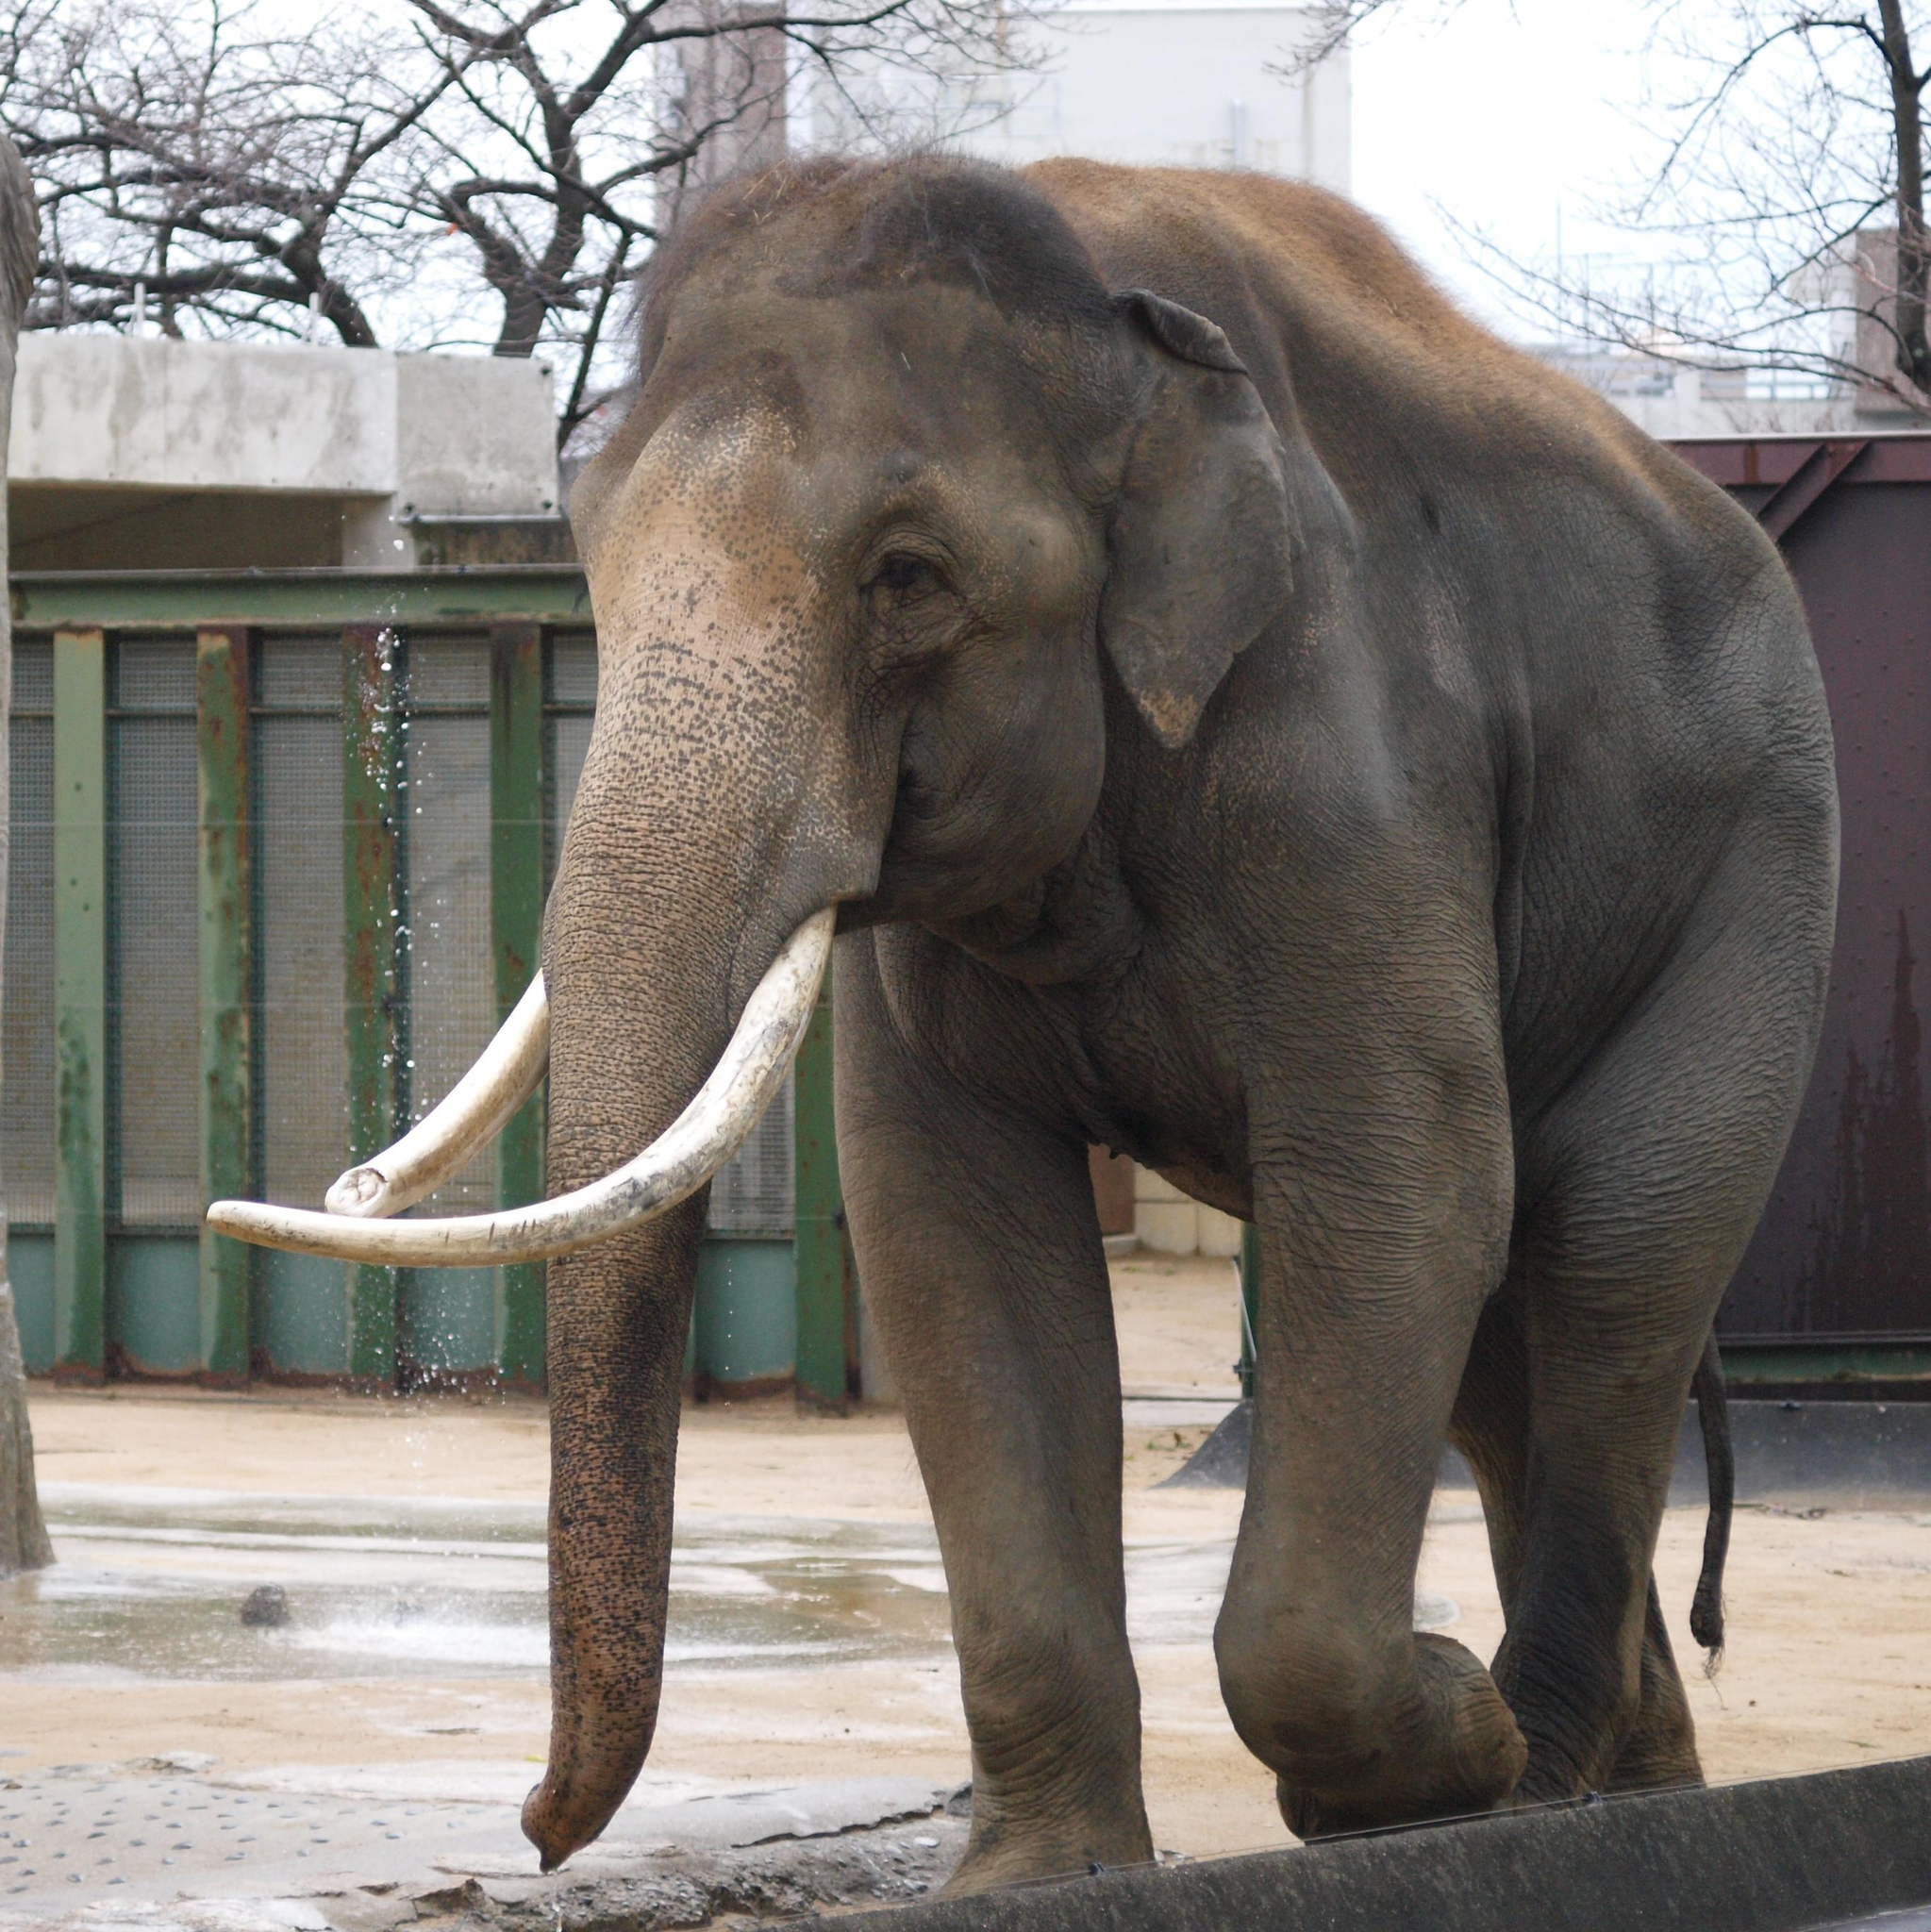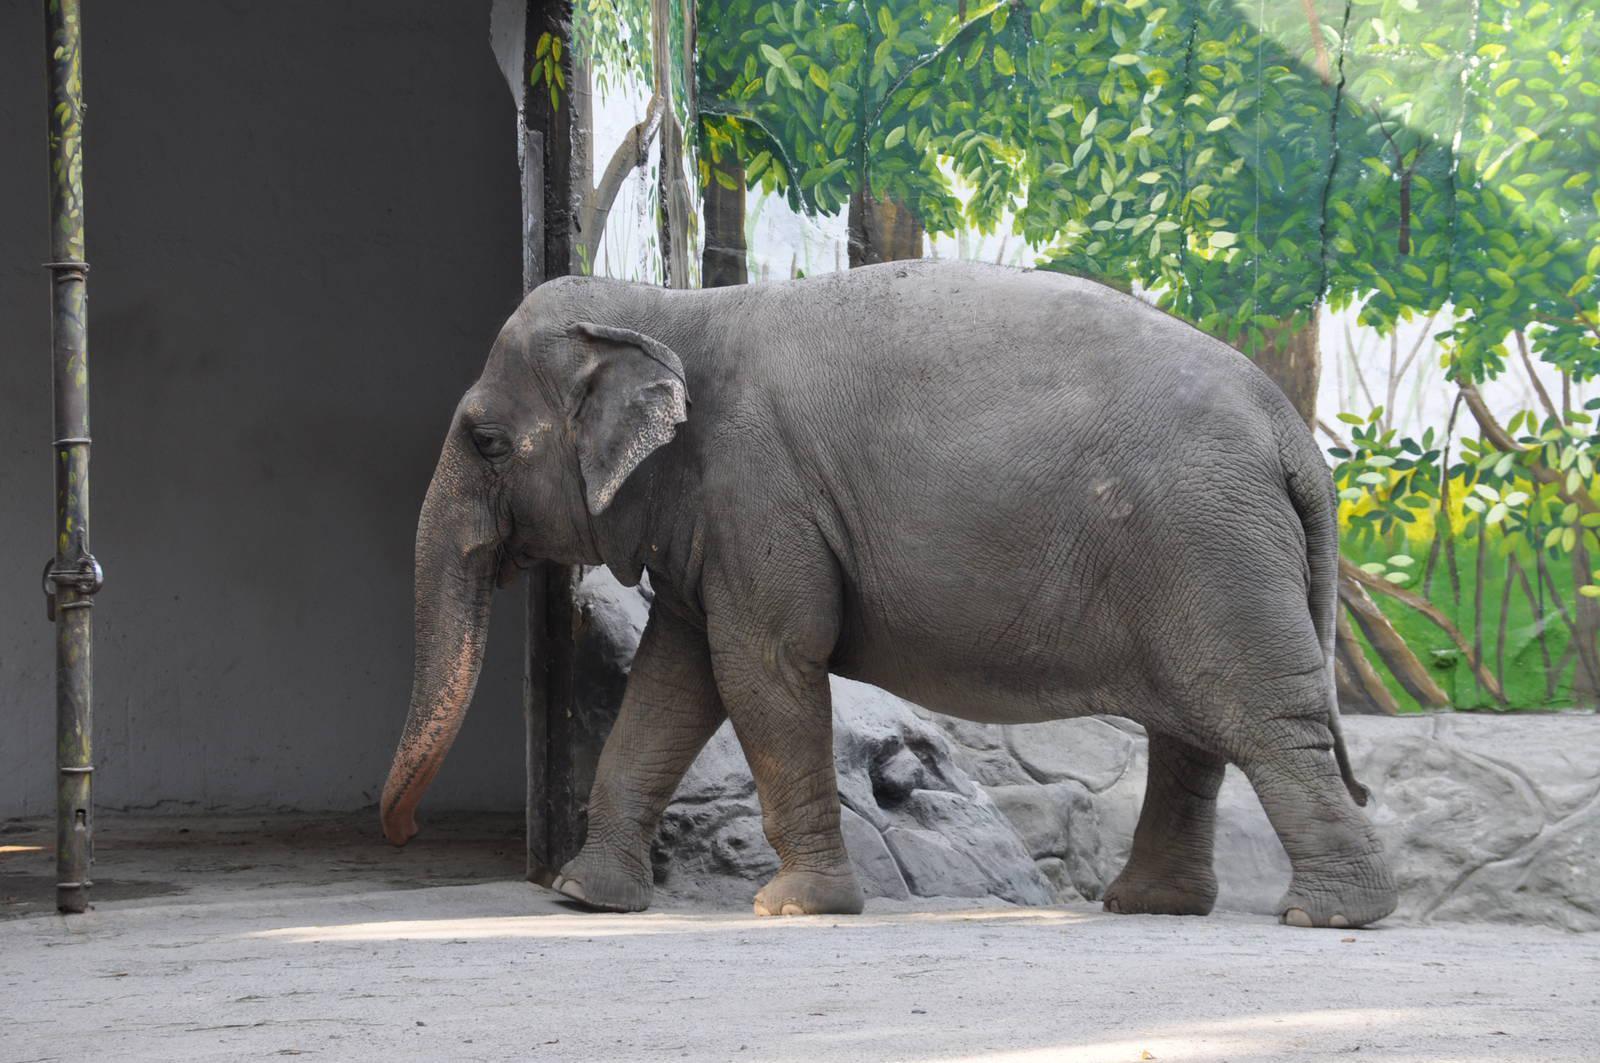The first image is the image on the left, the second image is the image on the right. Analyze the images presented: Is the assertion "There are at most 3 elephants in the pair of images." valid? Answer yes or no. Yes. 